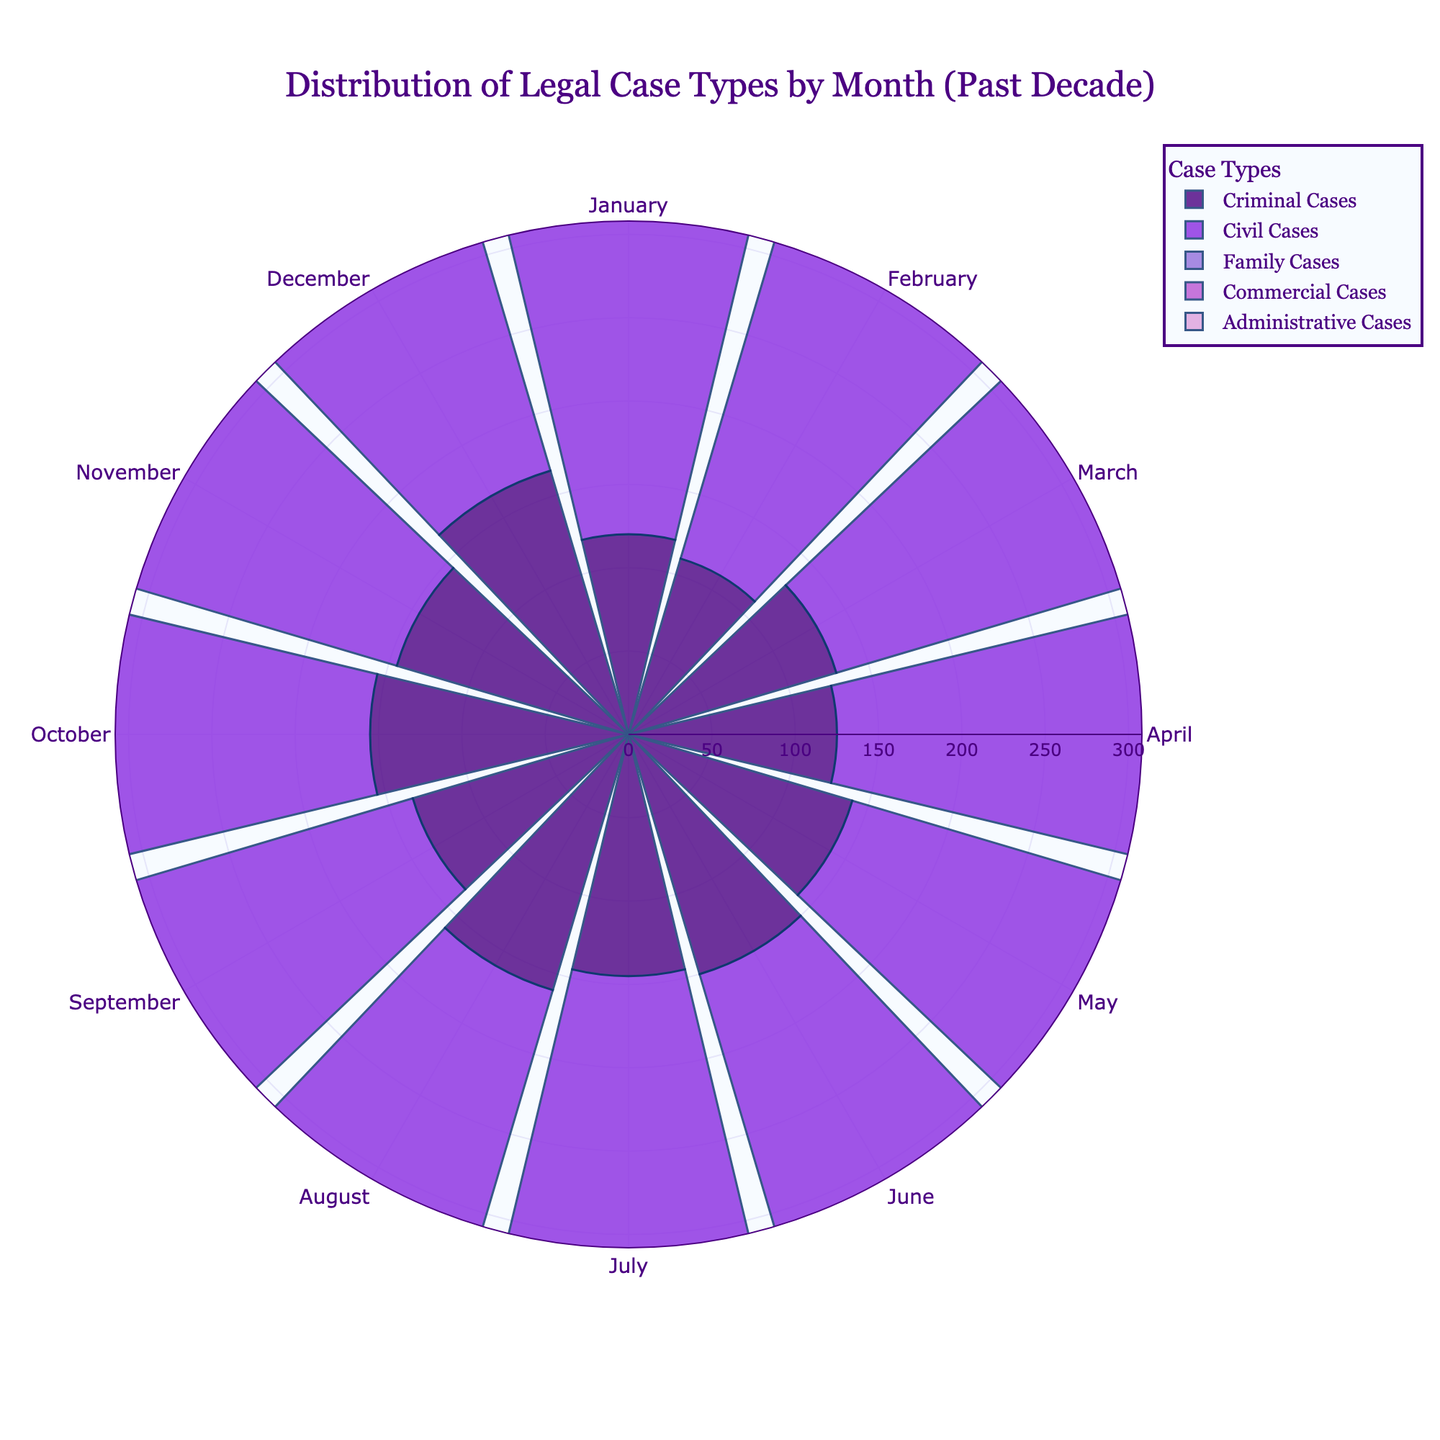What is the title of the figure? The title is prominently placed at the top of the figure and typically gives a clear description of the visualized data. Here, the title states the content and scope.
Answer: Distribution of Legal Case Types by Month (Past Decade) Which month shows the highest number of Criminal Cases? To answer this, look at the segment for Criminal Cases and observe the radial length corresponding to each month. The month with the longest segment represents the highest number.
Answer: December On average, which type of legal case has the highest average number per month? Calculate the average for each type of legal case by summing the monthly values and dividing by 12. Compare these averages to identify the highest.
Answer: Civil Cases Which month has the lowest number of Family Cases? Look at the segment for Family Cases and observe the radial length for each month. Identify the shortest segment corresponding to the lowest number.
Answer: February Are there any months where the number of Commercial Cases is equal to the number of Administrative Cases? Compare the radial lengths of the Commercial and Administrative Cases segments for each month to find if there are any equal lengths.
Answer: No How does the number of Family Cases in January compare to June? Compare the radial lengths for Family Cases in January and June. Identify which is longer or if they are equal.
Answer: January is lower than June In which month is the difference between Civil and Administrative Cases the greatest? For each month, subtract the number of Administrative Cases from the number of Civil Cases. Find the month with the highest difference.
Answer: November Which case type exhibits the least variation in numbers across the months? Determine the range (difference between maximum and minimum values) for each case type. The case type with the smallest range exhibits the least variation.
Answer: Administrative Cases Does the number of Commercial Cases show any particular seasonal pattern? Observe the radial lengths for Commercial Cases across the months to identify any repeating patterns or significant increases/decreases during specific seasons.
Answer: Yes, higher in the winter months Do Criminal Cases peak in a specific month or season? Look at the radial lengths for Criminal Cases and determine if there is a consistent peak in specific months or seasons.
Answer: Peaks in December 